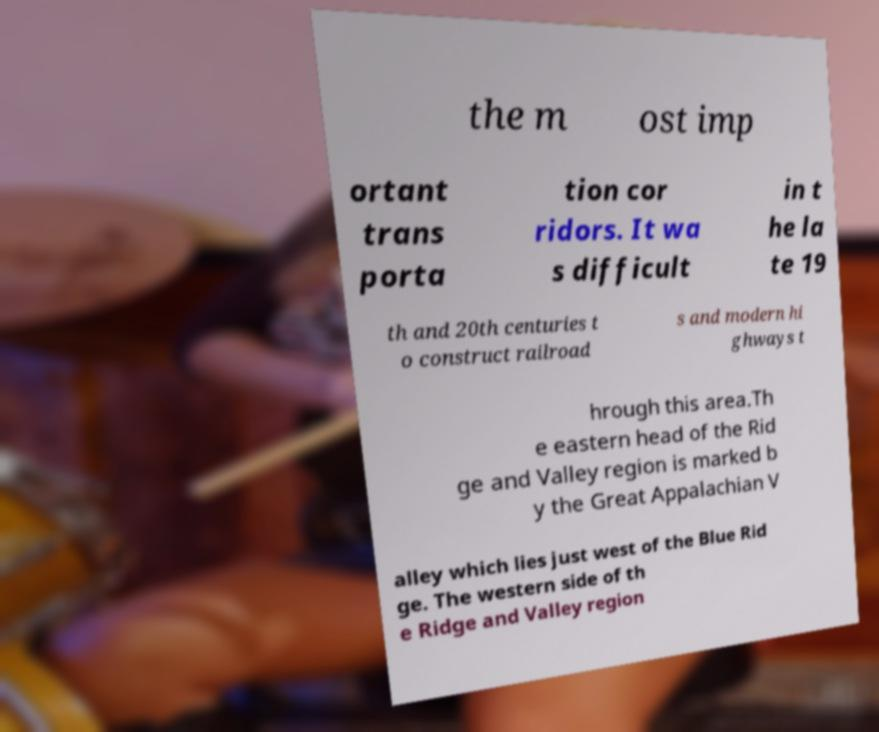Can you accurately transcribe the text from the provided image for me? the m ost imp ortant trans porta tion cor ridors. It wa s difficult in t he la te 19 th and 20th centuries t o construct railroad s and modern hi ghways t hrough this area.Th e eastern head of the Rid ge and Valley region is marked b y the Great Appalachian V alley which lies just west of the Blue Rid ge. The western side of th e Ridge and Valley region 